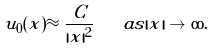Convert formula to latex. <formula><loc_0><loc_0><loc_500><loc_500>u _ { 0 } ( x ) \approx \frac { C } { | x | ^ { 2 } } \quad a s | x | \to \infty .</formula> 